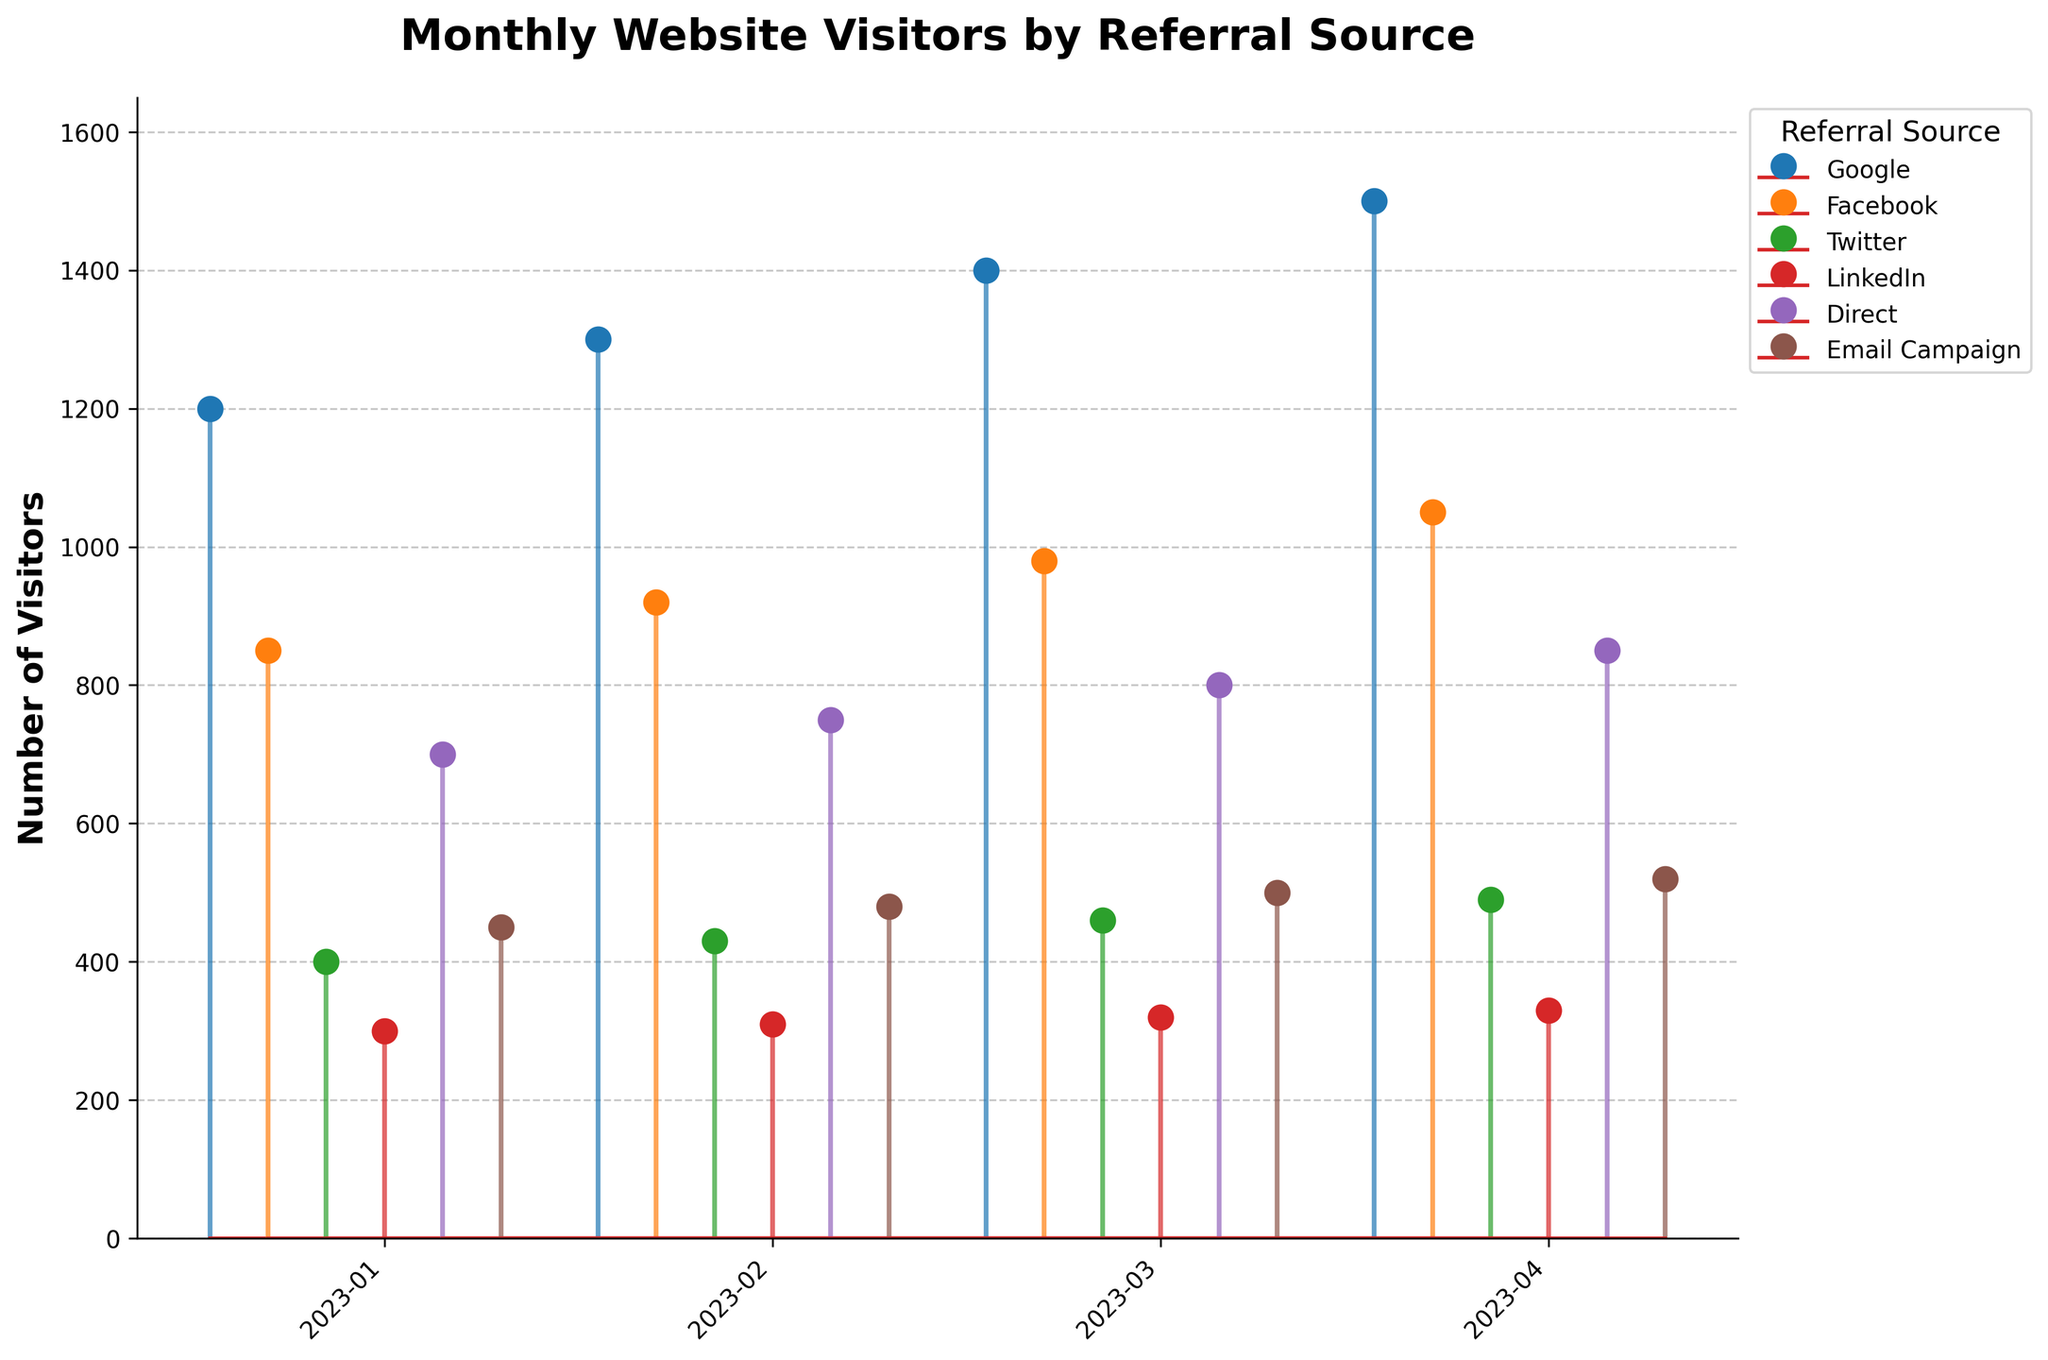what is the title of the figure? The title of the figure is generally shown at the top of the plot. In this case, it reads "Monthly Website Visitors by Referral Source."
Answer: Monthly Website Visitors by Referral Source What is the number of visitors from Google in April 2023? In the figure, you can see the stem representing Google referrals for April 2023 around the 1500 mark.
Answer: 1500 Which referral source has the least amount of visitors in January 2023? By examining the stems for January 2023, LinkedIn has the lowest stem, indicating it has the fewest visitors.
Answer: LinkedIn How many total visitors were there in March 2023 from all sources combined? To find out, add the visitors for each source in March 2023: 1400 (Google) + 980 (Facebook) + 460 (Twitter) + 320 (LinkedIn) + 800 (Direct) + 500 (Email Campaign) = 4460
Answer: 4460 Between Google and Facebook, which had more visitors in February 2023, and by how much? Google's stem is higher than Facebook's in February 2023. Specifically, Google had 1300 visitors, and Facebook had 920 visitors. The difference is 1300 - 920 = 380.
Answer: Google by 380 What is the average number of visitors per month from the Direct referral source? Sum up the monthly visitors from Direct: 700 (January) + 750 (February) + 800 (March) + 850 (April) = 3100. Divide this by the number of months (4): 3100 / 4 = 775.
Answer: 775 Did any referral source have a consistently increasing number of visitors each month? By following the stems month by month for each referral source, Google is consistently increasing: 1200 (January) to 1300 (February), 1400 (March), and 1500 (April).
Answer: Google In which month did Facebook see the highest number of visitors? The stem for Facebook reaches the highest point in April 2023.
Answer: April 2023 